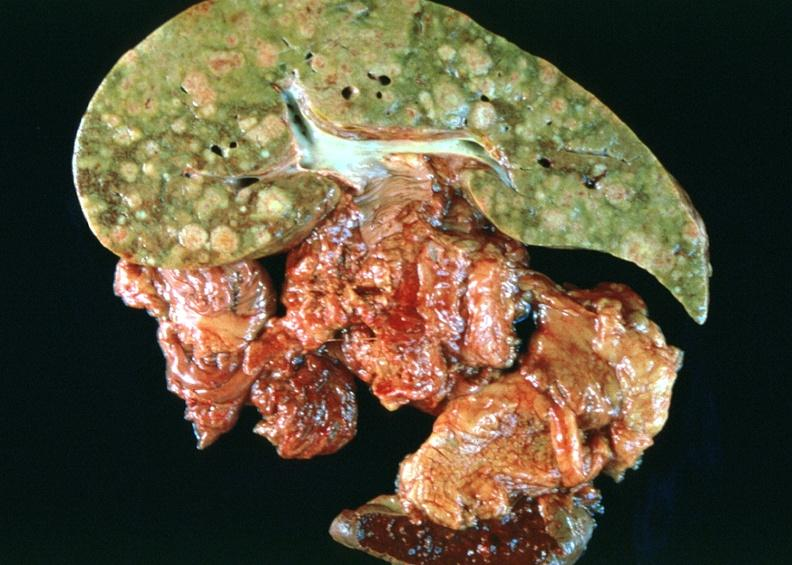what is present?
Answer the question using a single word or phrase. Hepatobiliary 